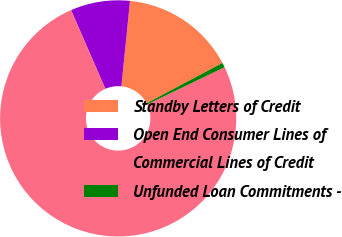Convert chart. <chart><loc_0><loc_0><loc_500><loc_500><pie_chart><fcel>Standby Letters of Credit<fcel>Open End Consumer Lines of<fcel>Commercial Lines of Credit<fcel>Unfunded Loan Commitments -<nl><fcel>15.63%<fcel>8.13%<fcel>75.6%<fcel>0.64%<nl></chart> 